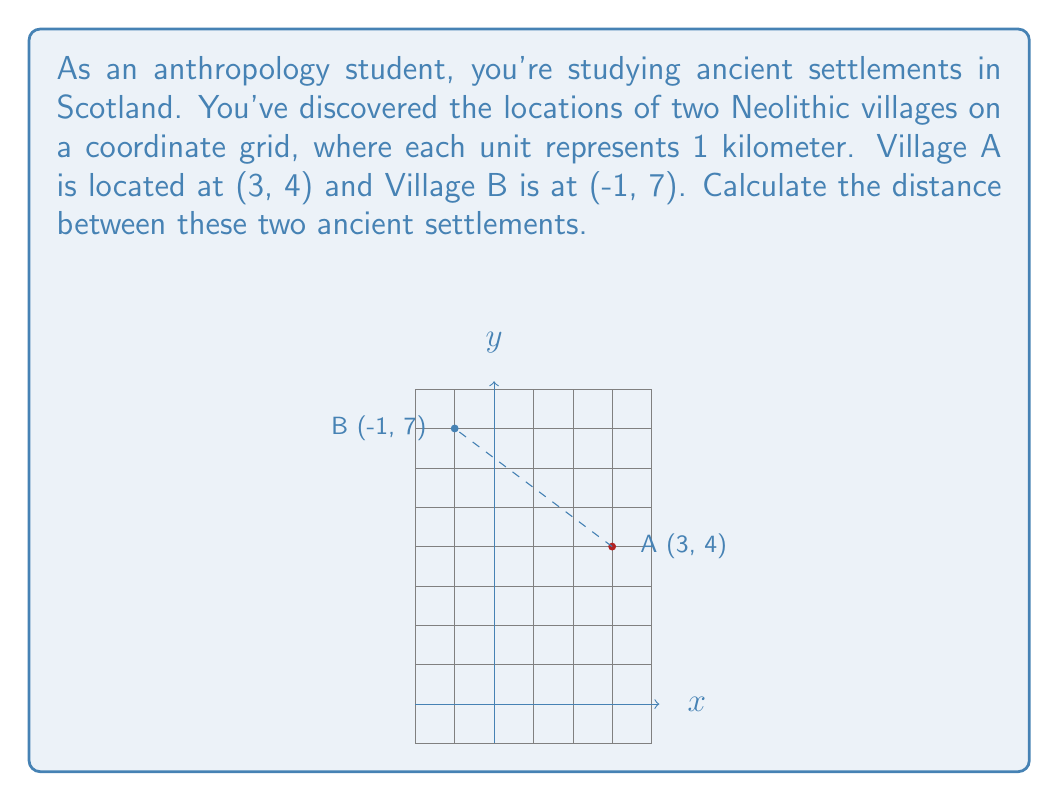What is the answer to this math problem? To find the distance between two points on a coordinate plane, we can use the distance formula, which is derived from the Pythagorean theorem:

$$d = \sqrt{(x_2 - x_1)^2 + (y_2 - y_1)^2}$$

Where $(x_1, y_1)$ are the coordinates of the first point and $(x_2, y_2)$ are the coordinates of the second point.

Let's plug in our values:
Village A: $(x_1, y_1) = (3, 4)$
Village B: $(x_2, y_2) = (-1, 7)$

Now, let's calculate:

1) $x_2 - x_1 = -1 - 3 = -4$
2) $y_2 - y_1 = 7 - 4 = 3$

Plugging these into the formula:

$$d = \sqrt{(-4)^2 + (3)^2}$$

3) Simplify inside the parentheses:
$$d = \sqrt{16 + 9}$$

4) Add under the square root:
$$d = \sqrt{25}$$

5) Simplify the square root:
$$d = 5$$

Since each unit represents 1 kilometer, the distance between the two villages is 5 kilometers.
Answer: 5 km 